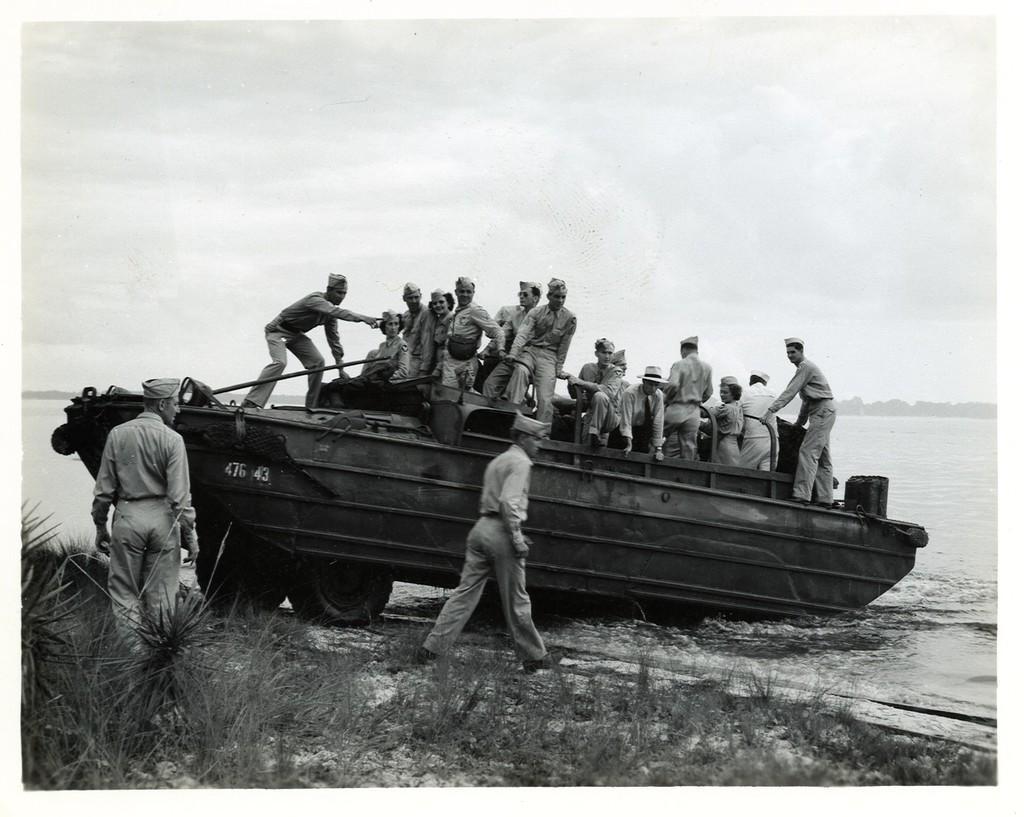Can you describe this image briefly? This image consists of a boat in which there are many people. At the bottom, there are two men walking. And there is a grass. To the right, there is water. At the top, there are clouds in the sky. 